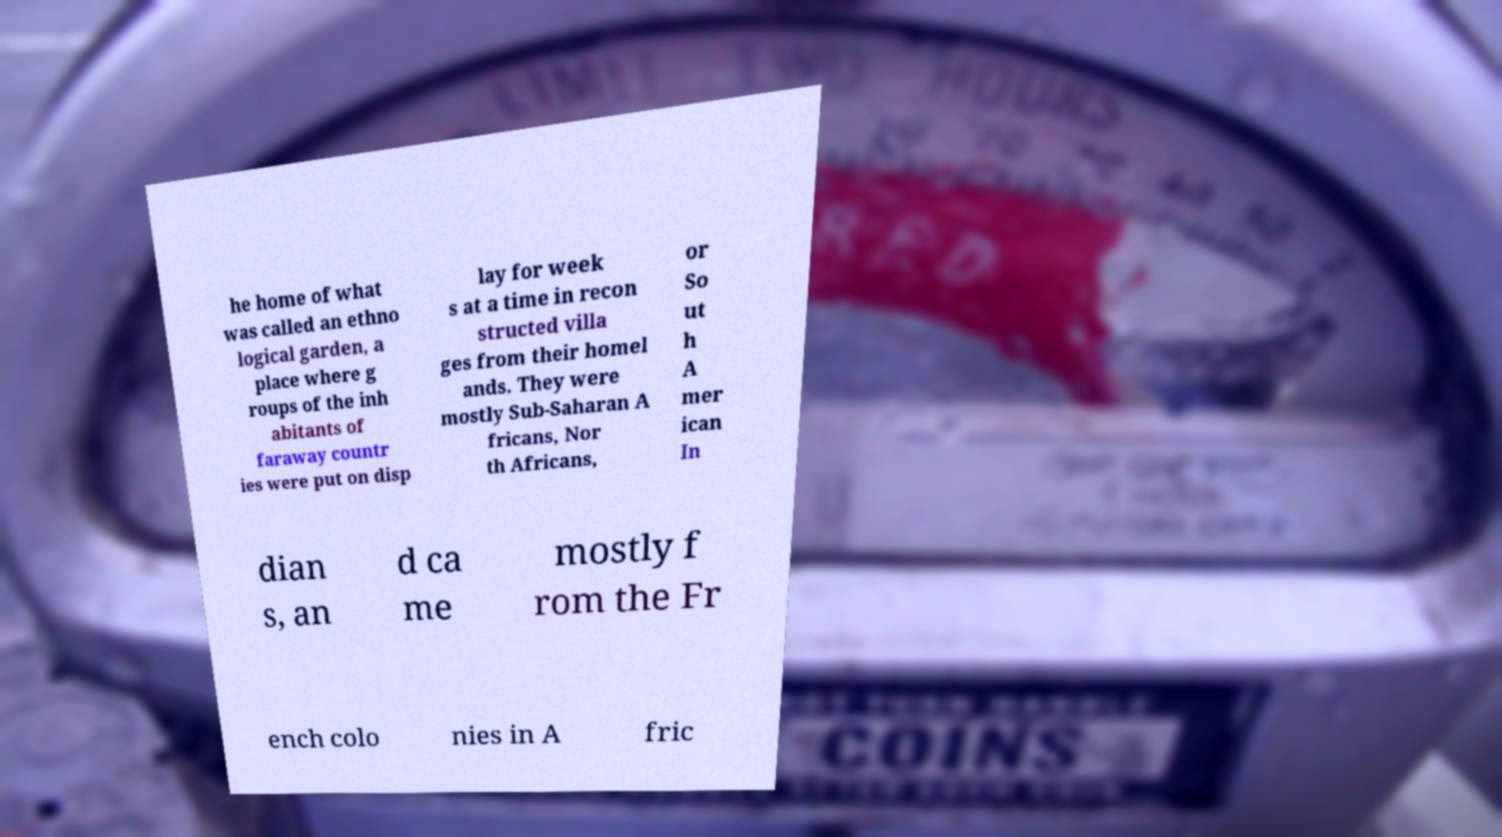There's text embedded in this image that I need extracted. Can you transcribe it verbatim? he home of what was called an ethno logical garden, a place where g roups of the inh abitants of faraway countr ies were put on disp lay for week s at a time in recon structed villa ges from their homel ands. They were mostly Sub-Saharan A fricans, Nor th Africans, or So ut h A mer ican In dian s, an d ca me mostly f rom the Fr ench colo nies in A fric 